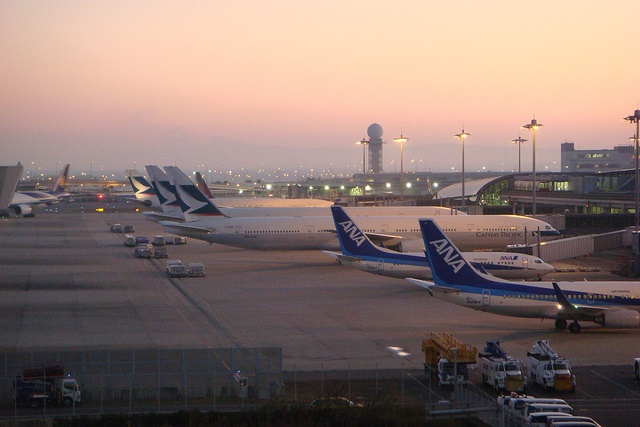Describe the objects in this image and their specific colors. I can see airplane in pink, gray, darkgray, and tan tones, airplane in pink, black, gray, and navy tones, airplane in pink, gray, navy, and black tones, truck in pink, black, maroon, and gray tones, and airplane in pink, tan, and gray tones in this image. 